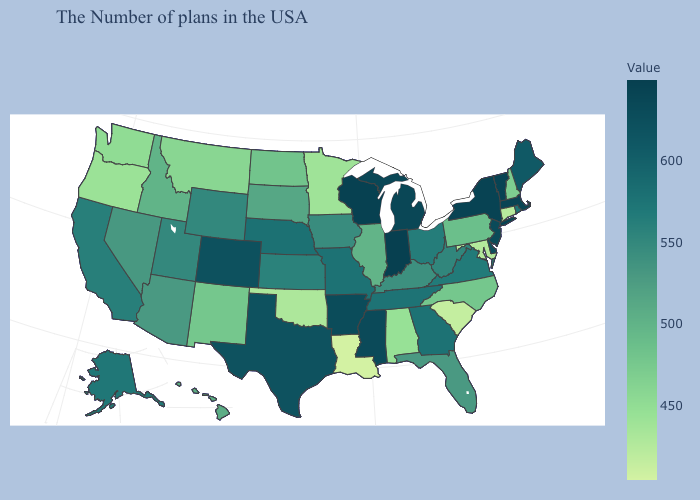Is the legend a continuous bar?
Answer briefly. Yes. Among the states that border Indiana , does Michigan have the highest value?
Short answer required. Yes. Does Colorado have the highest value in the West?
Write a very short answer. Yes. Which states hav the highest value in the South?
Answer briefly. Mississippi. Does Oregon have the lowest value in the USA?
Quick response, please. No. Does Mississippi have the highest value in the South?
Write a very short answer. Yes. Does the map have missing data?
Quick response, please. No. Does Virginia have the lowest value in the South?
Keep it brief. No. Does Virginia have a lower value than Massachusetts?
Keep it brief. Yes. 